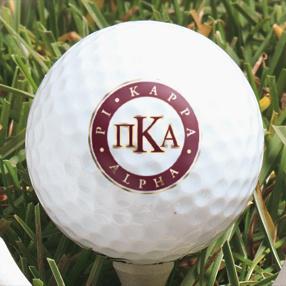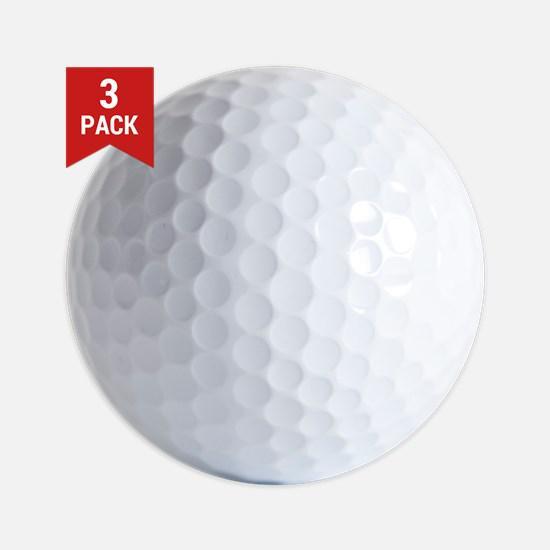The first image is the image on the left, the second image is the image on the right. Given the left and right images, does the statement "All balls are white and all balls have round-dimpled surfaces." hold true? Answer yes or no. Yes. The first image is the image on the left, the second image is the image on the right. For the images displayed, is the sentence "The left and right image contains a total of two golf balls." factually correct? Answer yes or no. Yes. 